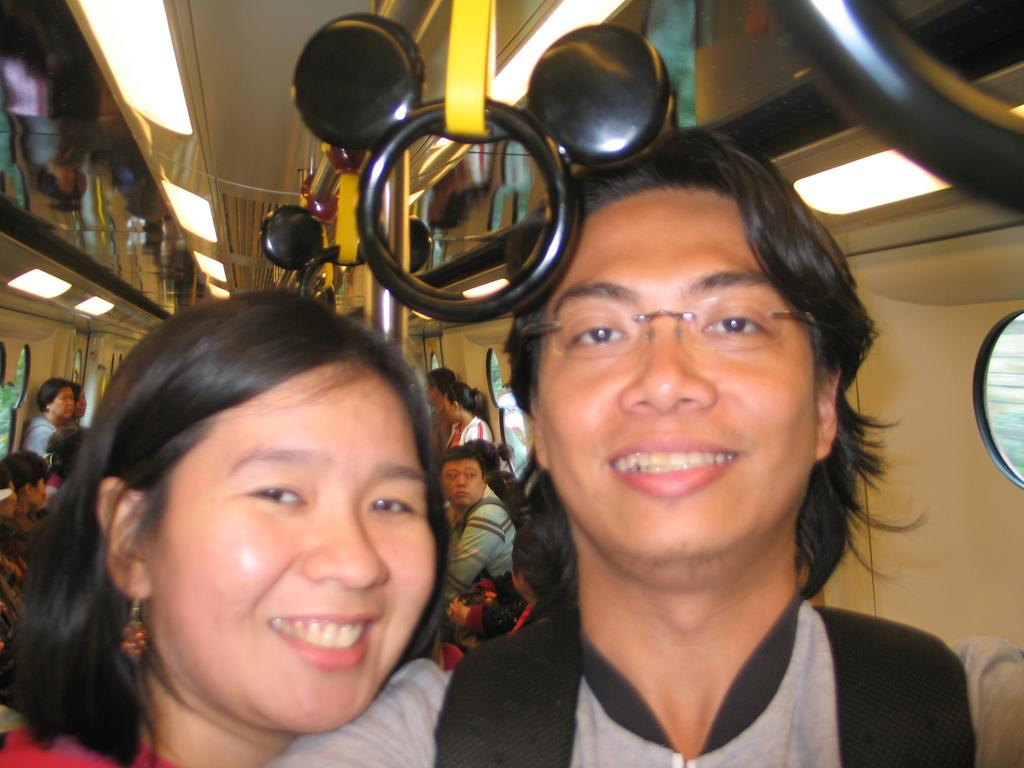What is happening in the image? There are people inside a vehicle in the image. Can you describe the vehicle? The facts provided do not give specific details about the vehicle, so we cannot describe it. How many people are inside the vehicle? The facts provided do not specify the number of people inside the vehicle, so we cannot determine the exact number. What type of brass instrument is being played by the people inside the vehicle? There is no brass instrument present in the image, as the facts only mention that there are people inside a vehicle. 